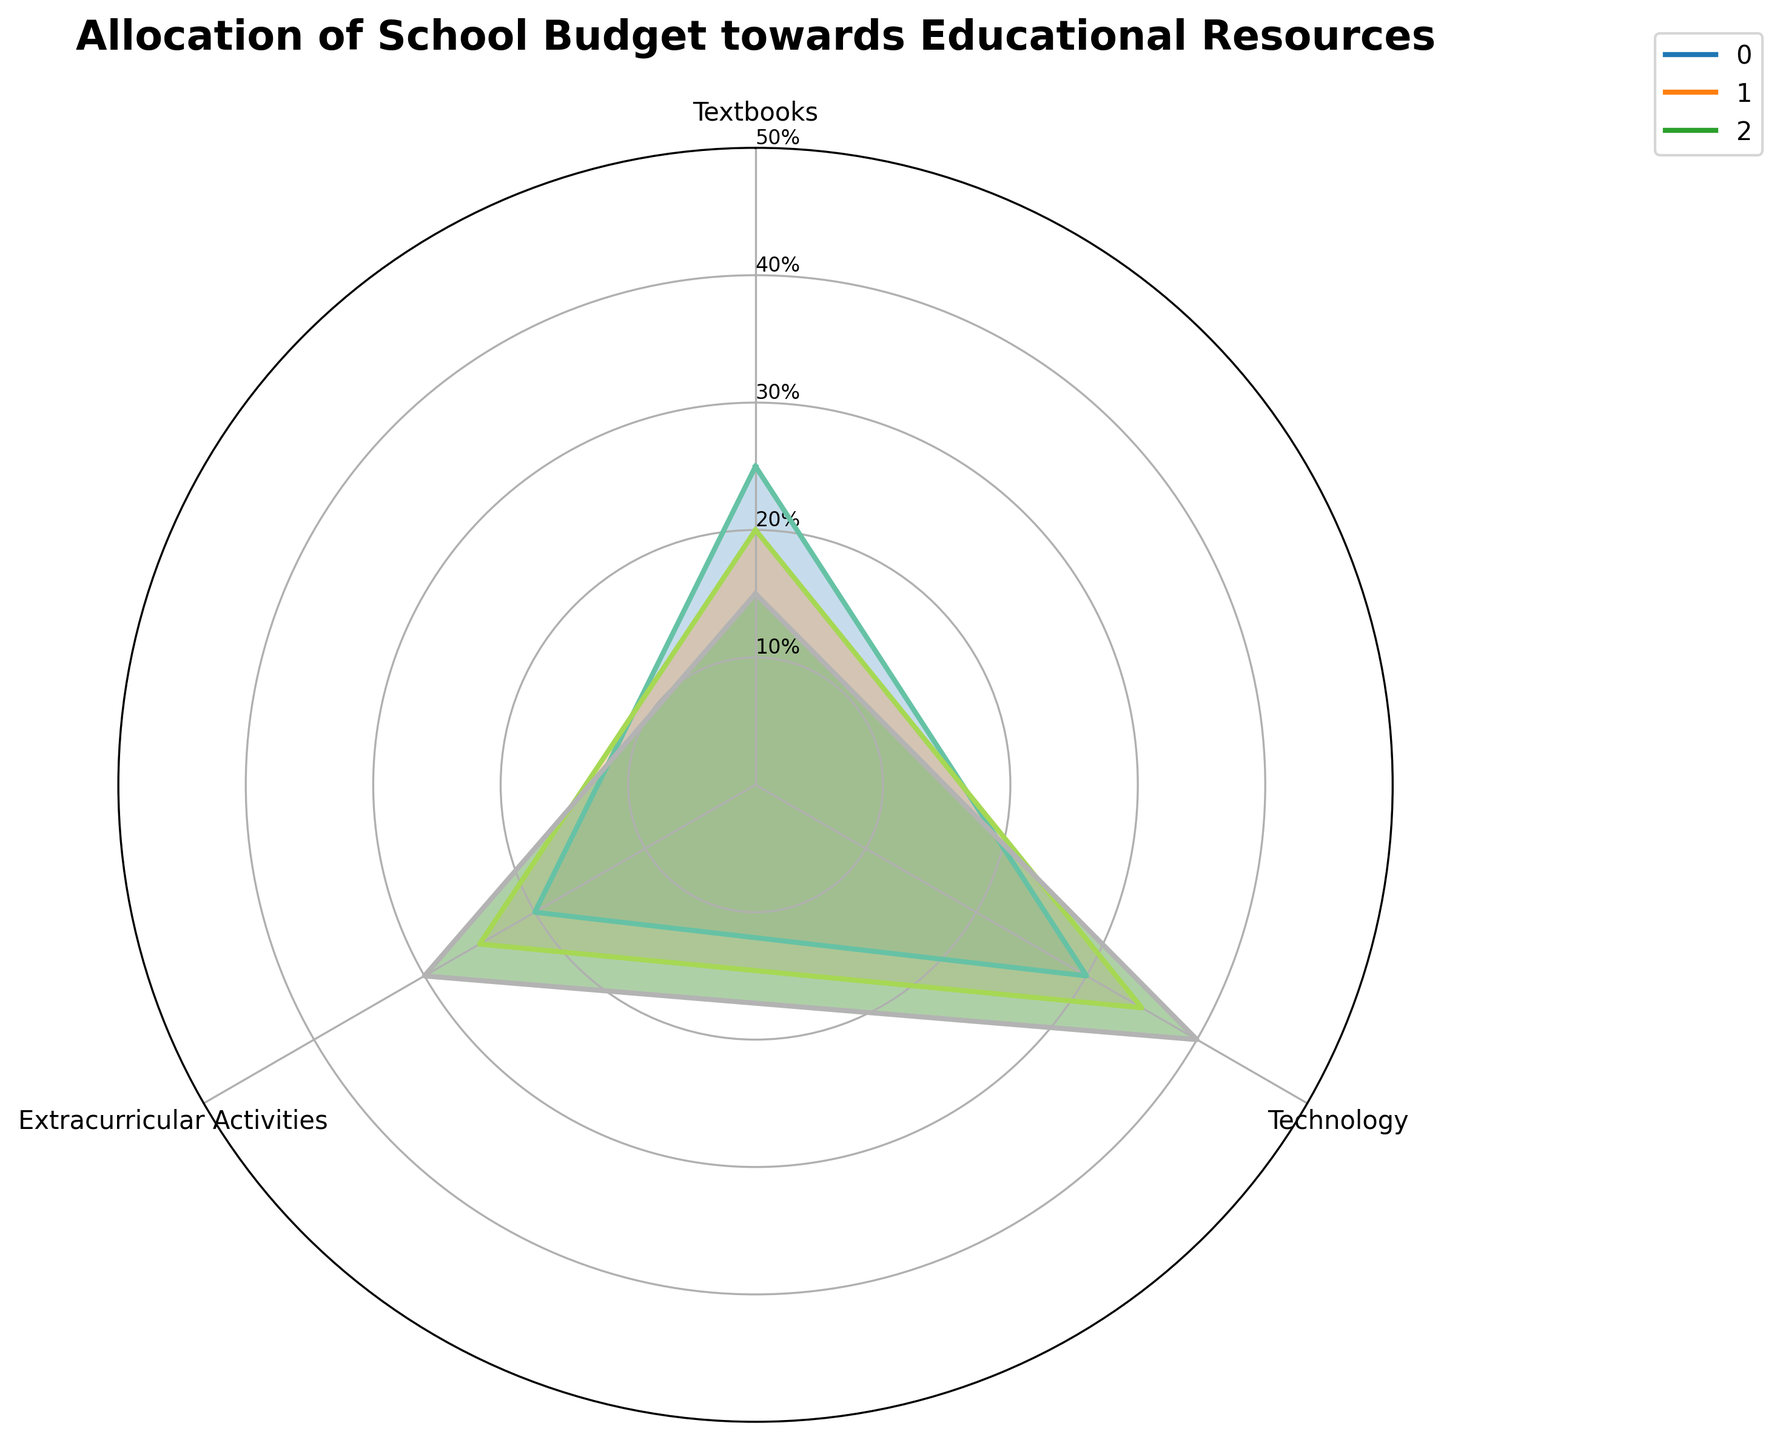How many school types are displayed in the chart? The chart represents the budget allocation of the three different school types. By looking at the plot with distinctly labeled lines and colors, we can identify three types, which are Primary Schools, Secondary Schools, and High Schools.
Answer: 3 Which educational resource category receives the highest allocation for High Schools? By observing the section labeled for High Schools and comparing values across the categories, Technology has the highest arc extension reaching 40%.
Answer: Technology In which school type is the allocation to Extracurricular Activities the highest? We compare the values indicated for the Extracurricular Activities across the three school types. High Schools show the highest allocation with their value arc extended to 30%.
Answer: High Schools What is the total percentage allocation towards Textbooks and Professional Development in Primary Schools? Identify the primary school's allocation values for Textbooks (25%) and Professional Development (25%), then sum them: 25% + 25% = 50%.
Answer: 50% Is the allocation to Technology in Secondary Schools greater or lower than that in Primary Schools? Look at the values for Technology in Secondary Schools (35%) and compare it to Primary Schools (30%). Secondary Schools have a higher allocation.
Answer: Greater Do any two educational resource categories have the same allocation percentage for any school type? Compare the values of the allocation for each school type across categories. In Primary Schools, Textbooks and Professional Development both are allocated 25%.
Answer: Yes Compare the allocation for Technology and Extracurricular Activities in High Schools, which category is allocated more? For High Schools, identify Technology (40%) and Extracurricular Activities (30%), and note that Technology has a higher allocation.
Answer: Technology What is the average allocation towards Technology across the three school types? Sum the Technology values for Primary (30%), Secondary (35%), and High Schools (40%). Divide by the number of school types: (30 + 35 + 40) / 3 = 35%.
Answer: 35% Which category shows a decreasing trend in allocation as you move from Primary Schools to High Schools? Track the values of each category from Primary to High Schools. Textbooks have values of 25%, 20%, and 15%, respectively, showing a decreasing trend.
Answer: Textbooks 